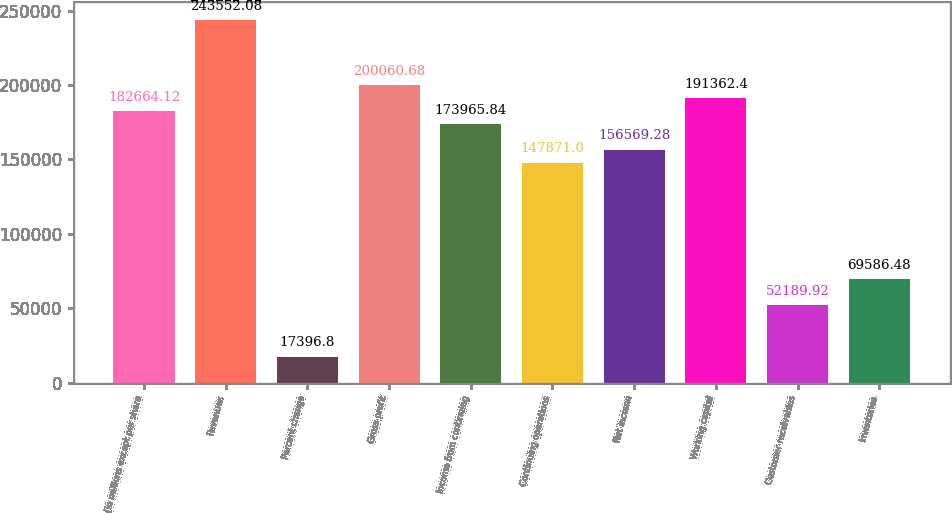Convert chart to OTSL. <chart><loc_0><loc_0><loc_500><loc_500><bar_chart><fcel>(In millions except per share<fcel>Revenues<fcel>Percent change<fcel>Gross profit<fcel>Income from continuing<fcel>Continuing operations<fcel>Net income<fcel>Working capital<fcel>Customer receivables<fcel>Inventories<nl><fcel>182664<fcel>243552<fcel>17396.8<fcel>200061<fcel>173966<fcel>147871<fcel>156569<fcel>191362<fcel>52189.9<fcel>69586.5<nl></chart> 